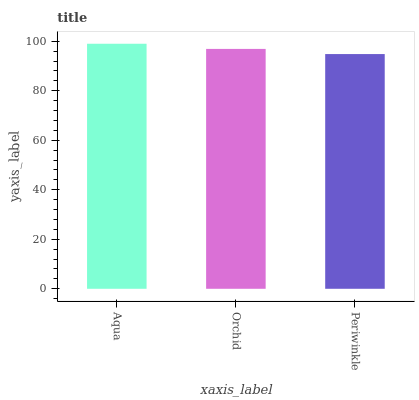Is Periwinkle the minimum?
Answer yes or no. Yes. Is Aqua the maximum?
Answer yes or no. Yes. Is Orchid the minimum?
Answer yes or no. No. Is Orchid the maximum?
Answer yes or no. No. Is Aqua greater than Orchid?
Answer yes or no. Yes. Is Orchid less than Aqua?
Answer yes or no. Yes. Is Orchid greater than Aqua?
Answer yes or no. No. Is Aqua less than Orchid?
Answer yes or no. No. Is Orchid the high median?
Answer yes or no. Yes. Is Orchid the low median?
Answer yes or no. Yes. Is Periwinkle the high median?
Answer yes or no. No. Is Aqua the low median?
Answer yes or no. No. 